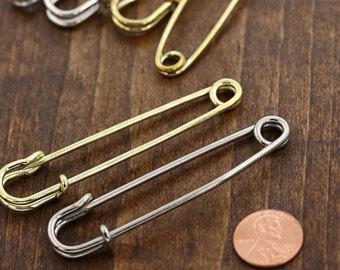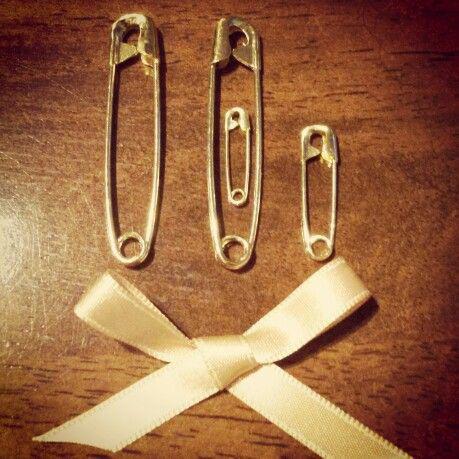The first image is the image on the left, the second image is the image on the right. For the images displayed, is the sentence "Some safety pins have letters and numbers on them." factually correct? Answer yes or no. No. 